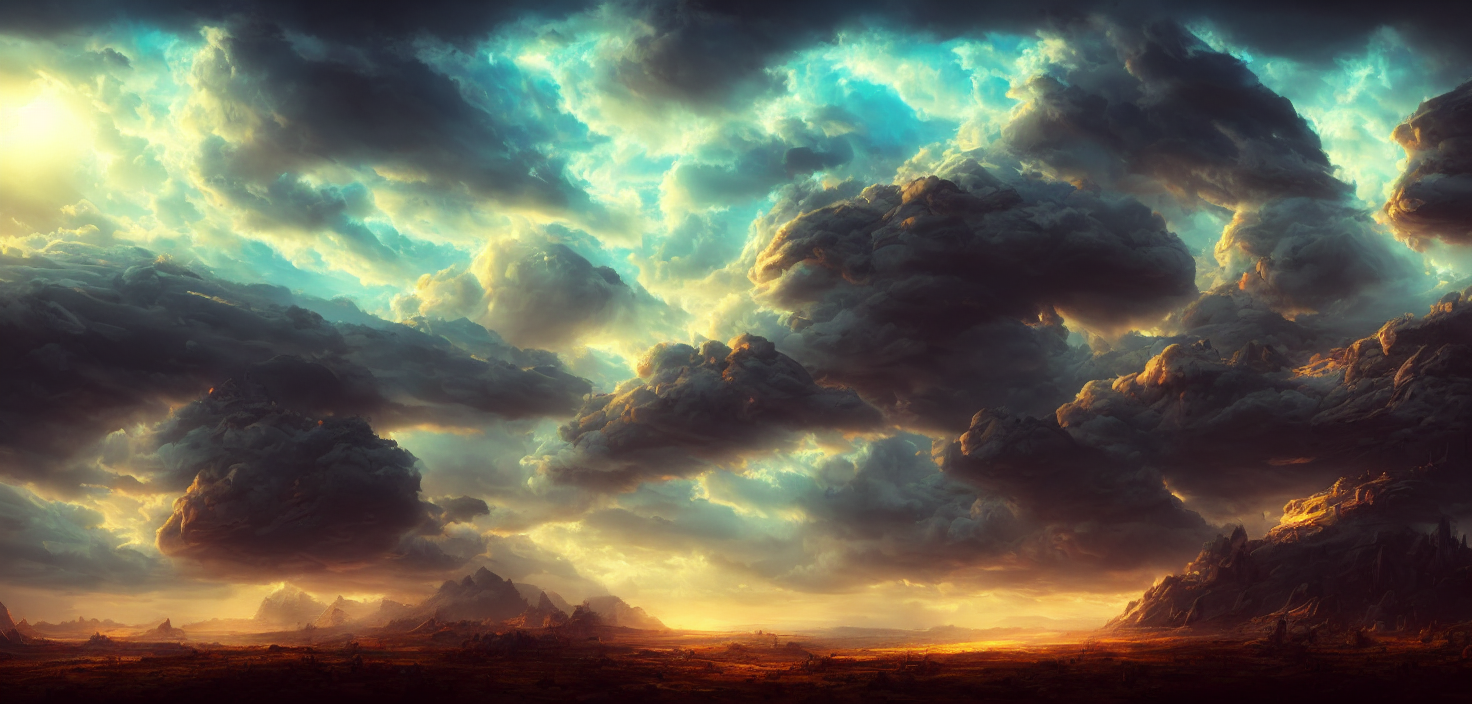What is the lighting like in the image? The lighting in the image strikes a harmonious balance, providing sufficient illumination without being overly intense. Sunlight filters through the clouds, creating a dynamic range of luminosity and shadow that adds depth and drama to the scene. 